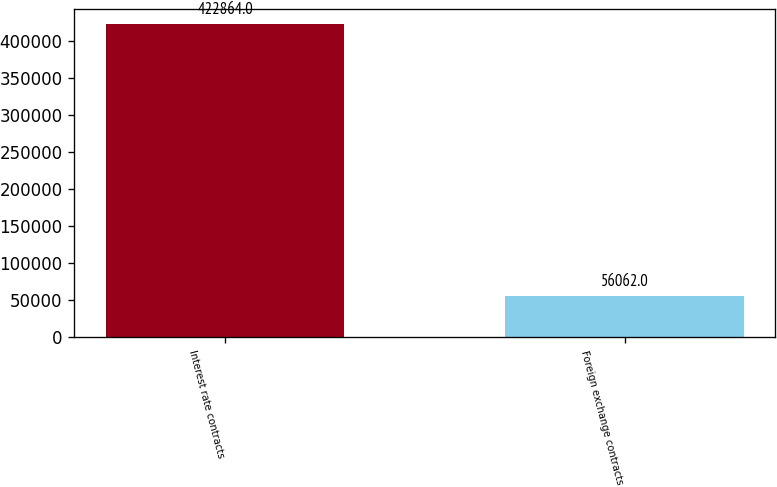Convert chart to OTSL. <chart><loc_0><loc_0><loc_500><loc_500><bar_chart><fcel>Interest rate contracts<fcel>Foreign exchange contracts<nl><fcel>422864<fcel>56062<nl></chart> 